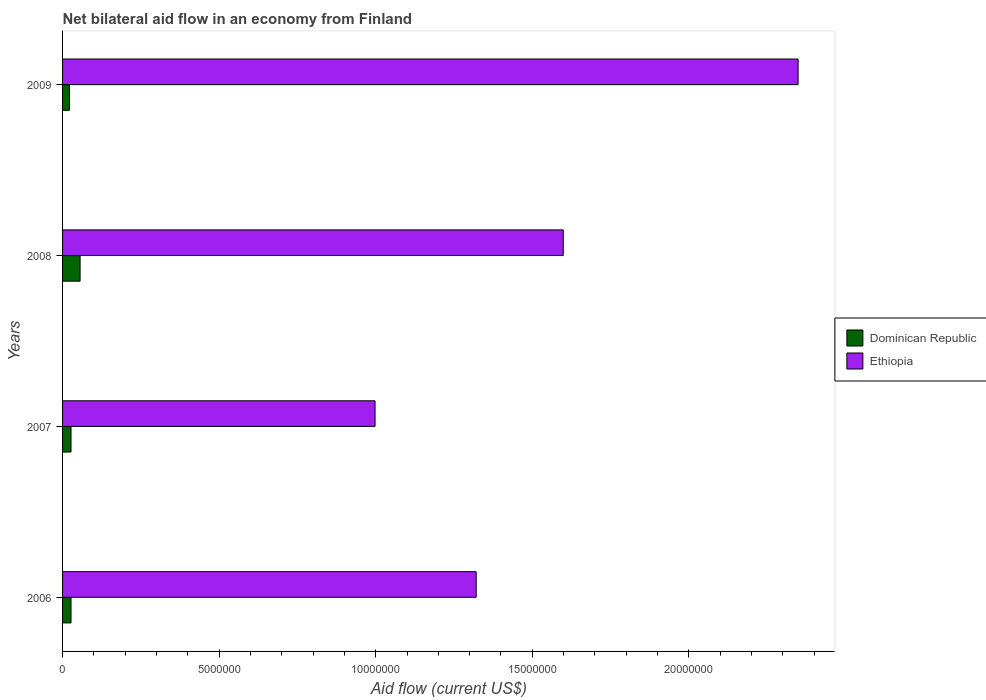How many different coloured bars are there?
Ensure brevity in your answer.  2. How many groups of bars are there?
Offer a terse response. 4. Are the number of bars per tick equal to the number of legend labels?
Provide a succinct answer. Yes. Are the number of bars on each tick of the Y-axis equal?
Provide a short and direct response. Yes. What is the net bilateral aid flow in Dominican Republic in 2009?
Offer a terse response. 2.20e+05. Across all years, what is the maximum net bilateral aid flow in Ethiopia?
Your response must be concise. 2.35e+07. In which year was the net bilateral aid flow in Dominican Republic minimum?
Offer a very short reply. 2009. What is the total net bilateral aid flow in Ethiopia in the graph?
Give a very brief answer. 6.27e+07. What is the difference between the net bilateral aid flow in Ethiopia in 2006 and that in 2007?
Ensure brevity in your answer.  3.23e+06. What is the difference between the net bilateral aid flow in Ethiopia in 2009 and the net bilateral aid flow in Dominican Republic in 2007?
Offer a very short reply. 2.32e+07. What is the average net bilateral aid flow in Ethiopia per year?
Your answer should be compact. 1.57e+07. In the year 2006, what is the difference between the net bilateral aid flow in Ethiopia and net bilateral aid flow in Dominican Republic?
Offer a terse response. 1.29e+07. Is the net bilateral aid flow in Ethiopia in 2006 less than that in 2008?
Provide a short and direct response. Yes. What is the difference between the highest and the lowest net bilateral aid flow in Ethiopia?
Your answer should be very brief. 1.35e+07. In how many years, is the net bilateral aid flow in Ethiopia greater than the average net bilateral aid flow in Ethiopia taken over all years?
Provide a succinct answer. 2. What does the 2nd bar from the top in 2008 represents?
Offer a very short reply. Dominican Republic. What does the 2nd bar from the bottom in 2009 represents?
Offer a very short reply. Ethiopia. Are all the bars in the graph horizontal?
Your response must be concise. Yes. How many years are there in the graph?
Your answer should be very brief. 4. What is the difference between two consecutive major ticks on the X-axis?
Your answer should be very brief. 5.00e+06. Does the graph contain any zero values?
Offer a very short reply. No. Where does the legend appear in the graph?
Your answer should be compact. Center right. What is the title of the graph?
Ensure brevity in your answer.  Net bilateral aid flow in an economy from Finland. What is the label or title of the X-axis?
Keep it short and to the point. Aid flow (current US$). What is the Aid flow (current US$) of Dominican Republic in 2006?
Provide a succinct answer. 2.70e+05. What is the Aid flow (current US$) of Ethiopia in 2006?
Provide a short and direct response. 1.32e+07. What is the Aid flow (current US$) of Ethiopia in 2007?
Provide a short and direct response. 9.98e+06. What is the Aid flow (current US$) in Dominican Republic in 2008?
Provide a short and direct response. 5.60e+05. What is the Aid flow (current US$) of Ethiopia in 2008?
Offer a terse response. 1.60e+07. What is the Aid flow (current US$) of Ethiopia in 2009?
Ensure brevity in your answer.  2.35e+07. Across all years, what is the maximum Aid flow (current US$) of Dominican Republic?
Provide a succinct answer. 5.60e+05. Across all years, what is the maximum Aid flow (current US$) of Ethiopia?
Keep it short and to the point. 2.35e+07. Across all years, what is the minimum Aid flow (current US$) in Ethiopia?
Your response must be concise. 9.98e+06. What is the total Aid flow (current US$) in Dominican Republic in the graph?
Your answer should be very brief. 1.32e+06. What is the total Aid flow (current US$) of Ethiopia in the graph?
Provide a short and direct response. 6.27e+07. What is the difference between the Aid flow (current US$) in Dominican Republic in 2006 and that in 2007?
Make the answer very short. 0. What is the difference between the Aid flow (current US$) of Ethiopia in 2006 and that in 2007?
Provide a short and direct response. 3.23e+06. What is the difference between the Aid flow (current US$) of Ethiopia in 2006 and that in 2008?
Offer a very short reply. -2.78e+06. What is the difference between the Aid flow (current US$) in Ethiopia in 2006 and that in 2009?
Offer a terse response. -1.03e+07. What is the difference between the Aid flow (current US$) of Ethiopia in 2007 and that in 2008?
Give a very brief answer. -6.01e+06. What is the difference between the Aid flow (current US$) of Ethiopia in 2007 and that in 2009?
Offer a very short reply. -1.35e+07. What is the difference between the Aid flow (current US$) in Ethiopia in 2008 and that in 2009?
Make the answer very short. -7.50e+06. What is the difference between the Aid flow (current US$) in Dominican Republic in 2006 and the Aid flow (current US$) in Ethiopia in 2007?
Provide a short and direct response. -9.71e+06. What is the difference between the Aid flow (current US$) of Dominican Republic in 2006 and the Aid flow (current US$) of Ethiopia in 2008?
Make the answer very short. -1.57e+07. What is the difference between the Aid flow (current US$) in Dominican Republic in 2006 and the Aid flow (current US$) in Ethiopia in 2009?
Your answer should be compact. -2.32e+07. What is the difference between the Aid flow (current US$) in Dominican Republic in 2007 and the Aid flow (current US$) in Ethiopia in 2008?
Make the answer very short. -1.57e+07. What is the difference between the Aid flow (current US$) in Dominican Republic in 2007 and the Aid flow (current US$) in Ethiopia in 2009?
Give a very brief answer. -2.32e+07. What is the difference between the Aid flow (current US$) in Dominican Republic in 2008 and the Aid flow (current US$) in Ethiopia in 2009?
Provide a succinct answer. -2.29e+07. What is the average Aid flow (current US$) of Ethiopia per year?
Your response must be concise. 1.57e+07. In the year 2006, what is the difference between the Aid flow (current US$) in Dominican Republic and Aid flow (current US$) in Ethiopia?
Offer a terse response. -1.29e+07. In the year 2007, what is the difference between the Aid flow (current US$) in Dominican Republic and Aid flow (current US$) in Ethiopia?
Offer a terse response. -9.71e+06. In the year 2008, what is the difference between the Aid flow (current US$) in Dominican Republic and Aid flow (current US$) in Ethiopia?
Offer a very short reply. -1.54e+07. In the year 2009, what is the difference between the Aid flow (current US$) of Dominican Republic and Aid flow (current US$) of Ethiopia?
Your answer should be compact. -2.33e+07. What is the ratio of the Aid flow (current US$) of Ethiopia in 2006 to that in 2007?
Keep it short and to the point. 1.32. What is the ratio of the Aid flow (current US$) of Dominican Republic in 2006 to that in 2008?
Ensure brevity in your answer.  0.48. What is the ratio of the Aid flow (current US$) of Ethiopia in 2006 to that in 2008?
Make the answer very short. 0.83. What is the ratio of the Aid flow (current US$) in Dominican Republic in 2006 to that in 2009?
Your answer should be compact. 1.23. What is the ratio of the Aid flow (current US$) of Ethiopia in 2006 to that in 2009?
Keep it short and to the point. 0.56. What is the ratio of the Aid flow (current US$) of Dominican Republic in 2007 to that in 2008?
Your response must be concise. 0.48. What is the ratio of the Aid flow (current US$) in Ethiopia in 2007 to that in 2008?
Offer a terse response. 0.62. What is the ratio of the Aid flow (current US$) in Dominican Republic in 2007 to that in 2009?
Provide a short and direct response. 1.23. What is the ratio of the Aid flow (current US$) in Ethiopia in 2007 to that in 2009?
Your answer should be very brief. 0.42. What is the ratio of the Aid flow (current US$) in Dominican Republic in 2008 to that in 2009?
Provide a short and direct response. 2.55. What is the ratio of the Aid flow (current US$) of Ethiopia in 2008 to that in 2009?
Give a very brief answer. 0.68. What is the difference between the highest and the second highest Aid flow (current US$) of Ethiopia?
Make the answer very short. 7.50e+06. What is the difference between the highest and the lowest Aid flow (current US$) in Ethiopia?
Make the answer very short. 1.35e+07. 